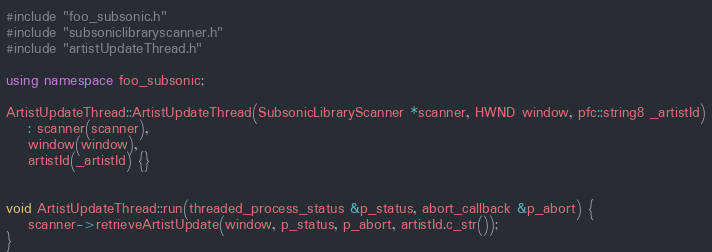Convert code to text. <code><loc_0><loc_0><loc_500><loc_500><_C++_>#include "foo_subsonic.h"
#include "subsoniclibraryscanner.h"
#include "artistUpdateThread.h"

using namespace foo_subsonic;

ArtistUpdateThread::ArtistUpdateThread(SubsonicLibraryScanner *scanner, HWND window, pfc::string8 _artistId)
	: scanner(scanner),
	window(window),
	artistId(_artistId) {}


void ArtistUpdateThread::run(threaded_process_status &p_status, abort_callback &p_abort) {
	scanner->retrieveArtistUpdate(window, p_status, p_abort, artistId.c_str());
}</code> 